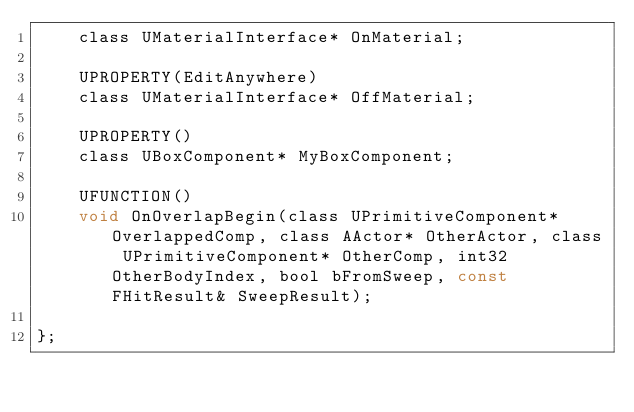Convert code to text. <code><loc_0><loc_0><loc_500><loc_500><_C_>	class UMaterialInterface* OnMaterial;

	UPROPERTY(EditAnywhere)
	class UMaterialInterface* OffMaterial;

	UPROPERTY()
	class UBoxComponent* MyBoxComponent;

	UFUNCTION()
	void OnOverlapBegin(class UPrimitiveComponent* OverlappedComp, class AActor* OtherActor, class UPrimitiveComponent* OtherComp, int32 OtherBodyIndex, bool bFromSweep, const FHitResult& SweepResult);
	
};
</code> 